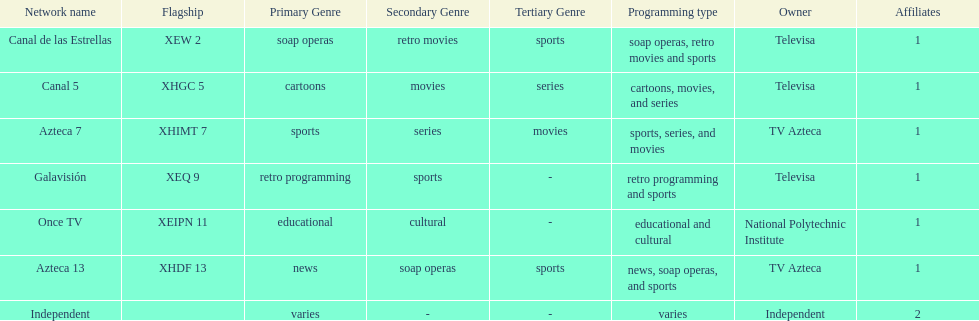Azteca 7 and azteca 13 are both owned by whom? TV Azteca. 